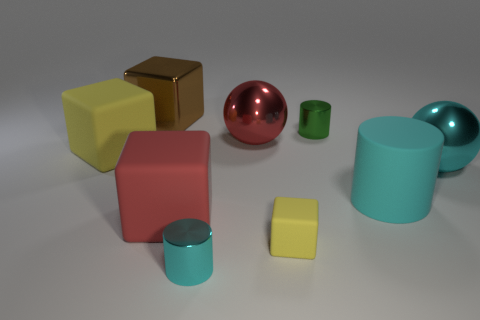Add 1 small gray metallic spheres. How many objects exist? 10 Subtract all balls. How many objects are left? 7 Add 3 small metallic objects. How many small metallic objects are left? 5 Add 7 green objects. How many green objects exist? 8 Subtract 0 purple spheres. How many objects are left? 9 Subtract all balls. Subtract all small yellow matte objects. How many objects are left? 6 